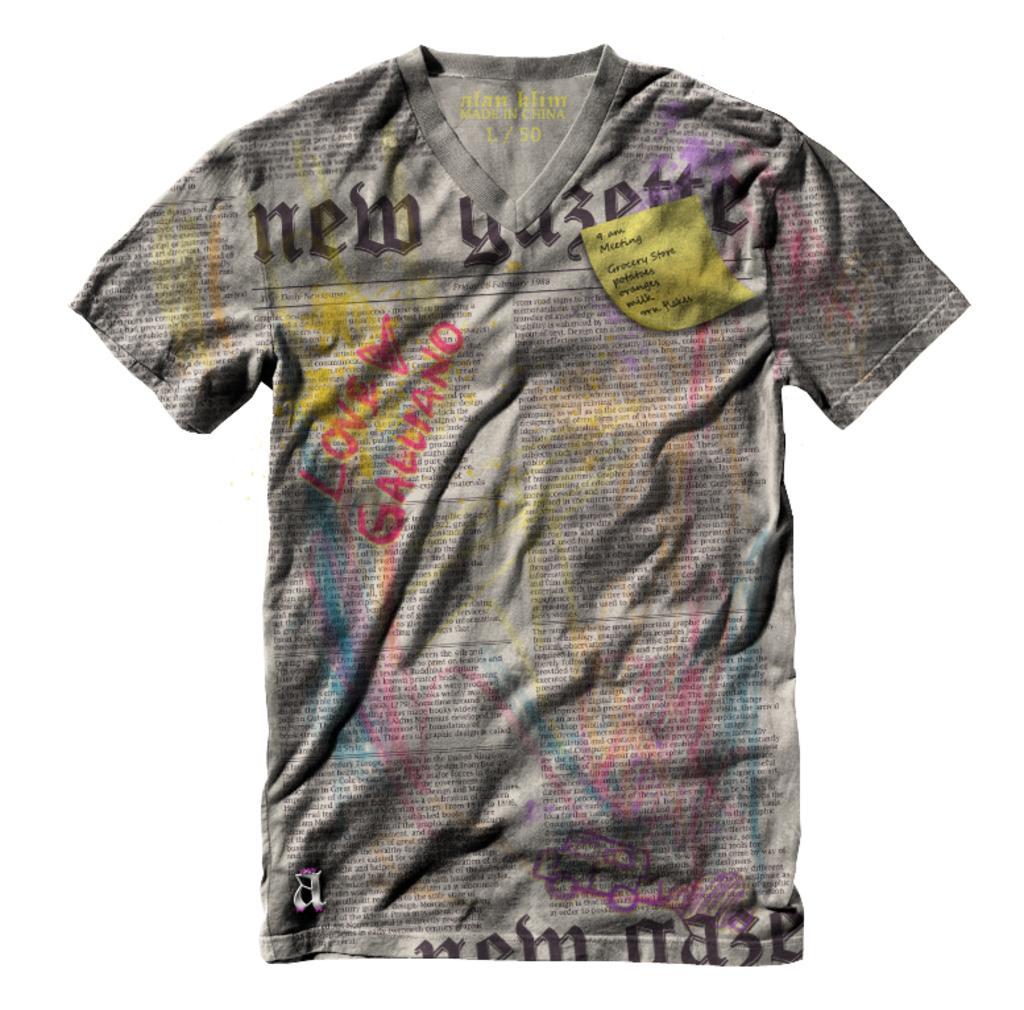Describe this image in one or two sentences. In this image, I can see a T-shirt with the print of words. There is a white background. 